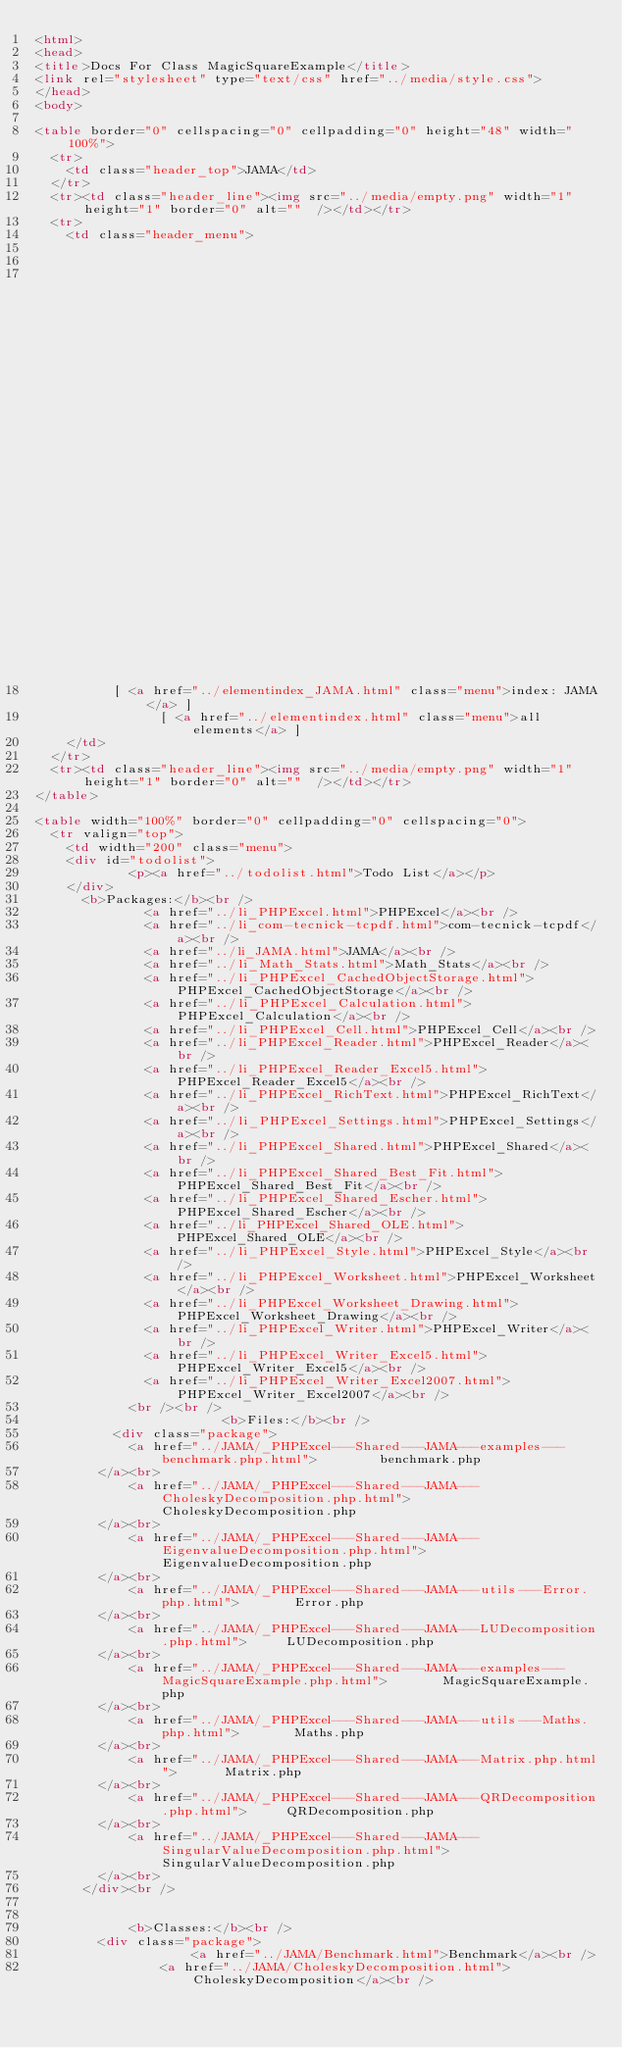Convert code to text. <code><loc_0><loc_0><loc_500><loc_500><_HTML_><html>
<head>
<title>Docs For Class MagicSquareExample</title>
<link rel="stylesheet" type="text/css" href="../media/style.css">
</head>
<body>

<table border="0" cellspacing="0" cellpadding="0" height="48" width="100%">
  <tr>
    <td class="header_top">JAMA</td>
  </tr>
  <tr><td class="header_line"><img src="../media/empty.png" width="1" height="1" border="0" alt=""  /></td></tr>
  <tr>
    <td class="header_menu">
        
                                                                            
                                                                                                                                                                                                                                                                                                                                                                                                      		  [ <a href="../classtrees_JAMA.html" class="menu">class tree: JAMA</a> ]
		  [ <a href="../elementindex_JAMA.html" class="menu">index: JAMA</a> ]
		  	    [ <a href="../elementindex.html" class="menu">all elements</a> ]
    </td>
  </tr>
  <tr><td class="header_line"><img src="../media/empty.png" width="1" height="1" border="0" alt=""  /></td></tr>
</table>

<table width="100%" border="0" cellpadding="0" cellspacing="0">
  <tr valign="top">
    <td width="200" class="menu">
	<div id="todolist">
			<p><a href="../todolist.html">Todo List</a></p>
	</div>
      <b>Packages:</b><br />
              <a href="../li_PHPExcel.html">PHPExcel</a><br />
              <a href="../li_com-tecnick-tcpdf.html">com-tecnick-tcpdf</a><br />
              <a href="../li_JAMA.html">JAMA</a><br />
              <a href="../li_Math_Stats.html">Math_Stats</a><br />
              <a href="../li_PHPExcel_CachedObjectStorage.html">PHPExcel_CachedObjectStorage</a><br />
              <a href="../li_PHPExcel_Calculation.html">PHPExcel_Calculation</a><br />
              <a href="../li_PHPExcel_Cell.html">PHPExcel_Cell</a><br />
              <a href="../li_PHPExcel_Reader.html">PHPExcel_Reader</a><br />
              <a href="../li_PHPExcel_Reader_Excel5.html">PHPExcel_Reader_Excel5</a><br />
              <a href="../li_PHPExcel_RichText.html">PHPExcel_RichText</a><br />
              <a href="../li_PHPExcel_Settings.html">PHPExcel_Settings</a><br />
              <a href="../li_PHPExcel_Shared.html">PHPExcel_Shared</a><br />
              <a href="../li_PHPExcel_Shared_Best_Fit.html">PHPExcel_Shared_Best_Fit</a><br />
              <a href="../li_PHPExcel_Shared_Escher.html">PHPExcel_Shared_Escher</a><br />
              <a href="../li_PHPExcel_Shared_OLE.html">PHPExcel_Shared_OLE</a><br />
              <a href="../li_PHPExcel_Style.html">PHPExcel_Style</a><br />
              <a href="../li_PHPExcel_Worksheet.html">PHPExcel_Worksheet</a><br />
              <a href="../li_PHPExcel_Worksheet_Drawing.html">PHPExcel_Worksheet_Drawing</a><br />
              <a href="../li_PHPExcel_Writer.html">PHPExcel_Writer</a><br />
              <a href="../li_PHPExcel_Writer_Excel5.html">PHPExcel_Writer_Excel5</a><br />
              <a href="../li_PHPExcel_Writer_Excel2007.html">PHPExcel_Writer_Excel2007</a><br />
            <br /><br />
                        <b>Files:</b><br />
      	  <div class="package">
			<a href="../JAMA/_PHPExcel---Shared---JAMA---examples---benchmark.php.html">		benchmark.php
		</a><br>
			<a href="../JAMA/_PHPExcel---Shared---JAMA---CholeskyDecomposition.php.html">		CholeskyDecomposition.php
		</a><br>
			<a href="../JAMA/_PHPExcel---Shared---JAMA---EigenvalueDecomposition.php.html">		EigenvalueDecomposition.php
		</a><br>
			<a href="../JAMA/_PHPExcel---Shared---JAMA---utils---Error.php.html">		Error.php
		</a><br>
			<a href="../JAMA/_PHPExcel---Shared---JAMA---LUDecomposition.php.html">		LUDecomposition.php
		</a><br>
			<a href="../JAMA/_PHPExcel---Shared---JAMA---examples---MagicSquareExample.php.html">		MagicSquareExample.php
		</a><br>
			<a href="../JAMA/_PHPExcel---Shared---JAMA---utils---Maths.php.html">		Maths.php
		</a><br>
			<a href="../JAMA/_PHPExcel---Shared---JAMA---Matrix.php.html">		Matrix.php
		</a><br>
			<a href="../JAMA/_PHPExcel---Shared---JAMA---QRDecomposition.php.html">		QRDecomposition.php
		</a><br>
			<a href="../JAMA/_PHPExcel---Shared---JAMA---SingularValueDecomposition.php.html">		SingularValueDecomposition.php
		</a><br>
	  </div><br />
      
      
            <b>Classes:</b><br />
        <div class="package">
		    		<a href="../JAMA/Benchmark.html">Benchmark</a><br />
	    		<a href="../JAMA/CholeskyDecomposition.html">CholeskyDecomposition</a><br /></code> 